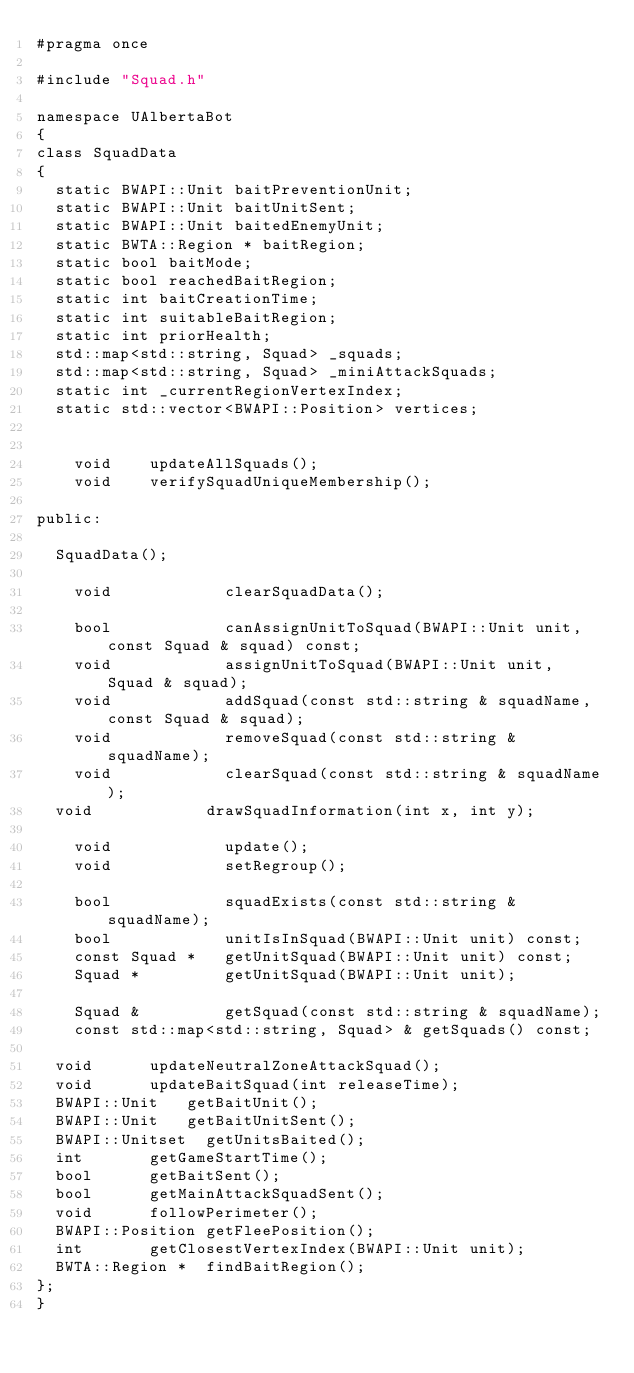Convert code to text. <code><loc_0><loc_0><loc_500><loc_500><_C_>#pragma once

#include "Squad.h"

namespace UAlbertaBot
{
class SquadData
{
	static BWAPI::Unit baitPreventionUnit;
	static BWAPI::Unit baitUnitSent;
	static BWAPI::Unit baitedEnemyUnit;
	static BWTA::Region * baitRegion;
	static bool baitMode;
	static bool reachedBaitRegion;
	static int baitCreationTime;
	static int suitableBaitRegion;
	static int priorHealth;
	std::map<std::string, Squad> _squads;
	std::map<std::string, Squad> _miniAttackSquads;
	static int _currentRegionVertexIndex;
	static std::vector<BWAPI::Position> vertices;


    void    updateAllSquads();
    void    verifySquadUniqueMembership();

public:

	SquadData();

    void            clearSquadData();
	
    bool            canAssignUnitToSquad(BWAPI::Unit unit, const Squad & squad) const;
    void            assignUnitToSquad(BWAPI::Unit unit, Squad & squad);
    void            addSquad(const std::string & squadName, const Squad & squad);
    void            removeSquad(const std::string & squadName);
    void            clearSquad(const std::string & squadName);
	void            drawSquadInformation(int x, int y);

    void            update();
    void            setRegroup();

    bool            squadExists(const std::string & squadName);
    bool            unitIsInSquad(BWAPI::Unit unit) const;
    const Squad *   getUnitSquad(BWAPI::Unit unit) const;
    Squad *         getUnitSquad(BWAPI::Unit unit);

    Squad &         getSquad(const std::string & squadName);
    const std::map<std::string, Squad> & getSquads() const;

	void			updateNeutralZoneAttackSquad();
	void			updateBaitSquad(int releaseTime);
	BWAPI::Unit		getBaitUnit();
	BWAPI::Unit		getBaitUnitSent();
	BWAPI::Unitset	getUnitsBaited();
	int				getGameStartTime();
	bool			getBaitSent();
	bool			getMainAttackSquadSent();
	void			followPerimeter();
	BWAPI::Position getFleePosition();
	int				getClosestVertexIndex(BWAPI::Unit unit);
	BWTA::Region *	findBaitRegion();
};
}</code> 